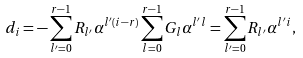Convert formula to latex. <formula><loc_0><loc_0><loc_500><loc_500>d _ { i } = - \sum _ { l ^ { \prime } = 0 } ^ { r - 1 } R _ { l ^ { \prime } } \alpha ^ { l ^ { \prime } ( i - r ) } \sum _ { l = 0 } ^ { r - 1 } G _ { l } \alpha ^ { l ^ { \prime } l } = \sum _ { l ^ { \prime } = 0 } ^ { r - 1 } R _ { l ^ { \prime } } \alpha ^ { l ^ { \prime } i } ,</formula> 